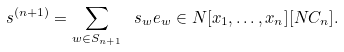<formula> <loc_0><loc_0><loc_500><loc_500>\ s ^ { ( n + 1 ) } = \sum _ { w \in S _ { n + 1 } } \ s _ { w } e _ { w } \in { N } [ x _ { 1 } , \dots , x _ { n } ] [ N C _ { n } ] .</formula> 